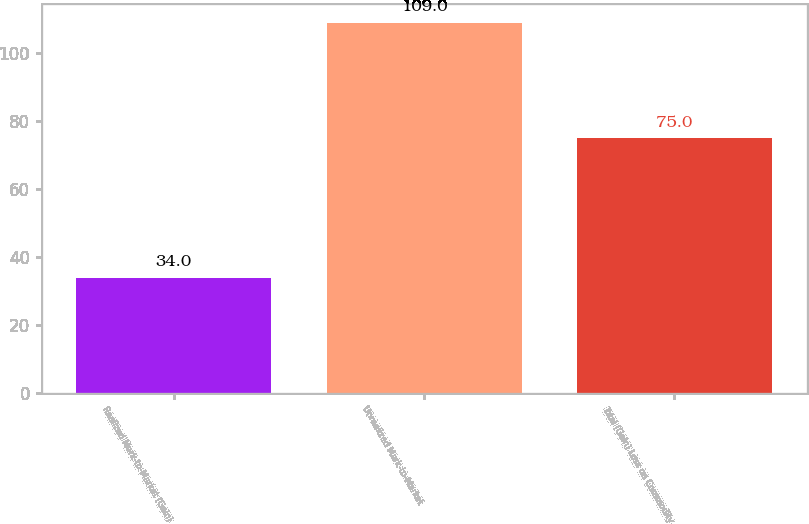<chart> <loc_0><loc_0><loc_500><loc_500><bar_chart><fcel>Realized Mark-to-Market (Gain)<fcel>Unrealized Mark-to-Market<fcel>Total (Gain) Loss on Commodity<nl><fcel>34<fcel>109<fcel>75<nl></chart> 